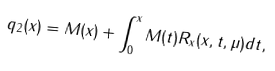Convert formula to latex. <formula><loc_0><loc_0><loc_500><loc_500>q _ { 2 } ( x ) = M ( x ) + \int _ { 0 } ^ { x } M ( t ) R _ { x } ( x , t , \mu ) d t ,</formula> 